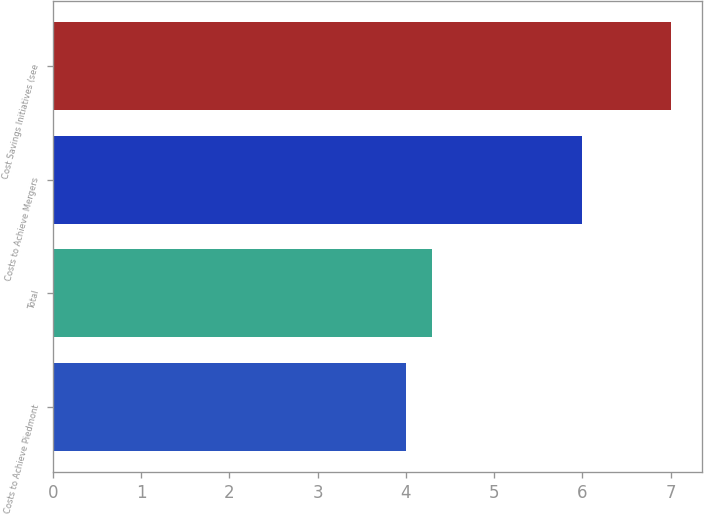<chart> <loc_0><loc_0><loc_500><loc_500><bar_chart><fcel>Costs to Achieve Piedmont<fcel>Total<fcel>Costs to Achieve Mergers<fcel>Cost Savings Initiatives (see<nl><fcel>4<fcel>4.3<fcel>6<fcel>7<nl></chart> 